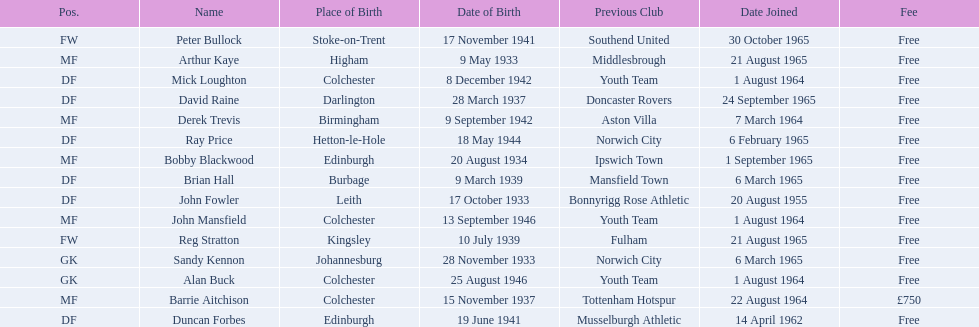Which team was ray price on before he started for this team? Norwich City. 